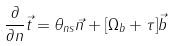Convert formula to latex. <formula><loc_0><loc_0><loc_500><loc_500>\frac { \partial } { { \partial } n } \vec { t } = { \theta } _ { n s } \vec { n } + [ { \Omega } _ { b } + { \tau } ] \vec { b }</formula> 